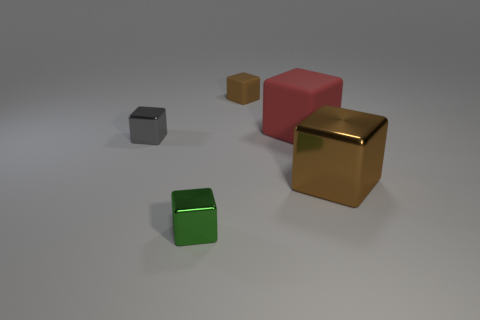Do the large metal object and the small rubber block have the same color?
Your answer should be very brief. Yes. There is a block that is on the left side of the big red matte block and to the right of the green thing; what is its size?
Your response must be concise. Small. Are there fewer gray objects than small metallic objects?
Provide a succinct answer. Yes. There is a matte cube that is behind the big red block; how big is it?
Your answer should be compact. Small. The metal thing that is both left of the red block and behind the small green metal object has what shape?
Your answer should be compact. Cube. What size is the gray object that is the same shape as the green object?
Your answer should be very brief. Small. What number of other red things are the same material as the big red object?
Offer a terse response. 0. Does the small matte thing have the same color as the shiny block that is on the left side of the tiny green block?
Provide a succinct answer. No. Is the number of brown matte blocks greater than the number of tiny yellow balls?
Ensure brevity in your answer.  Yes. The big matte thing is what color?
Offer a very short reply. Red. 